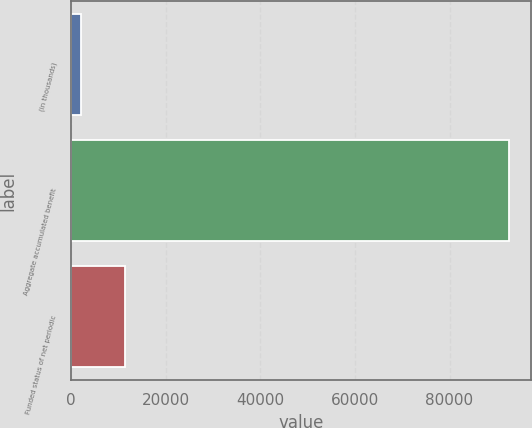Convert chart to OTSL. <chart><loc_0><loc_0><loc_500><loc_500><bar_chart><fcel>(in thousands)<fcel>Aggregate accumulated benefit<fcel>Funded status of net periodic<nl><fcel>2004<fcel>92611<fcel>11496<nl></chart> 